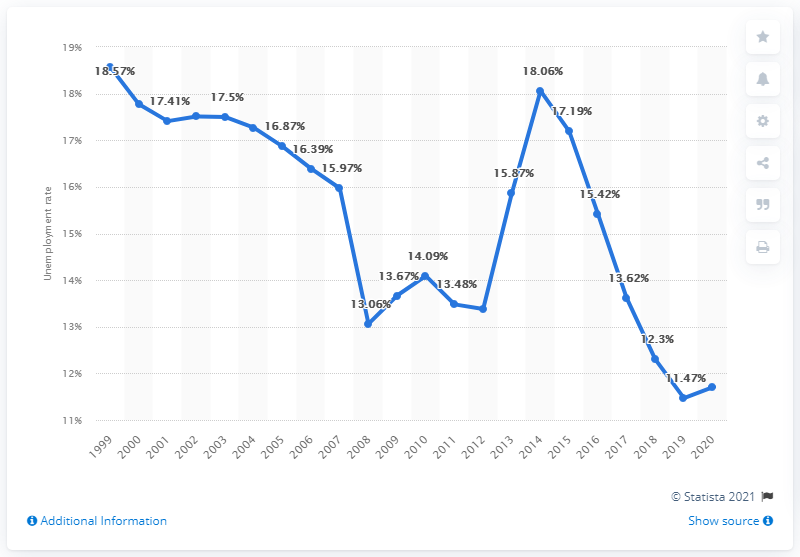Outline some significant characteristics in this image. In 2020, the unemployment rate in Albania was 11.7%. 